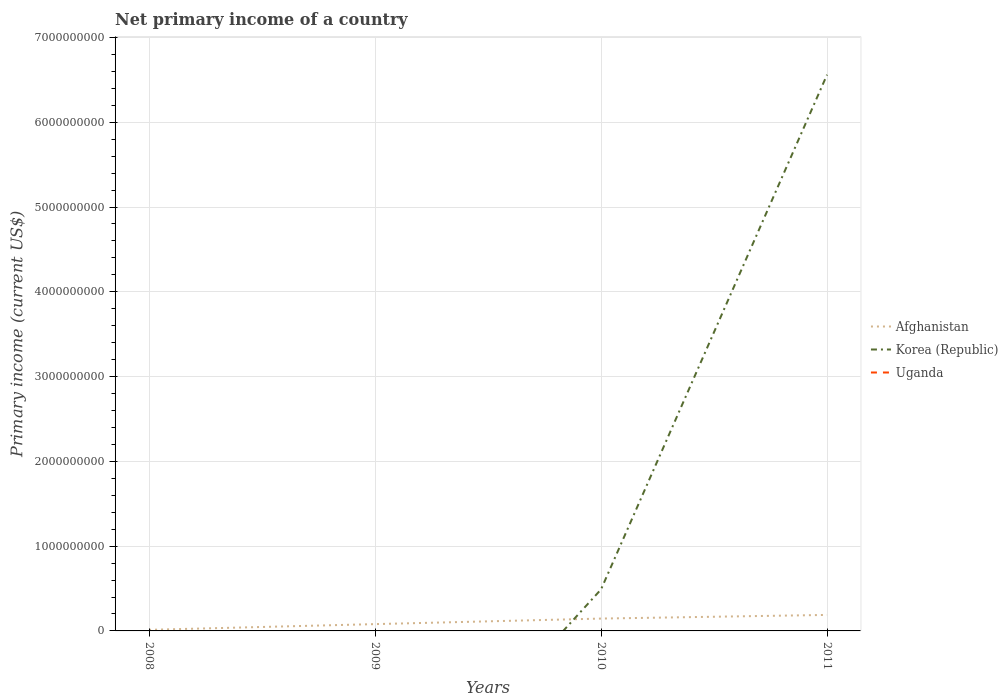Does the line corresponding to Uganda intersect with the line corresponding to Korea (Republic)?
Make the answer very short. Yes. Is the number of lines equal to the number of legend labels?
Offer a very short reply. No. Across all years, what is the maximum primary income in Afghanistan?
Ensure brevity in your answer.  1.28e+07. What is the total primary income in Korea (Republic) in the graph?
Provide a short and direct response. -6.07e+09. What is the difference between the highest and the second highest primary income in Afghanistan?
Your answer should be compact. 1.76e+08. What is the difference between the highest and the lowest primary income in Uganda?
Your response must be concise. 0. How many years are there in the graph?
Offer a very short reply. 4. How many legend labels are there?
Provide a short and direct response. 3. What is the title of the graph?
Make the answer very short. Net primary income of a country. Does "Georgia" appear as one of the legend labels in the graph?
Your answer should be very brief. No. What is the label or title of the Y-axis?
Make the answer very short. Primary income (current US$). What is the Primary income (current US$) in Afghanistan in 2008?
Your answer should be compact. 1.28e+07. What is the Primary income (current US$) of Korea (Republic) in 2008?
Your answer should be compact. 0. What is the Primary income (current US$) of Uganda in 2008?
Give a very brief answer. 0. What is the Primary income (current US$) of Afghanistan in 2009?
Your response must be concise. 8.03e+07. What is the Primary income (current US$) in Afghanistan in 2010?
Keep it short and to the point. 1.46e+08. What is the Primary income (current US$) in Korea (Republic) in 2010?
Keep it short and to the point. 4.90e+08. What is the Primary income (current US$) of Afghanistan in 2011?
Make the answer very short. 1.89e+08. What is the Primary income (current US$) in Korea (Republic) in 2011?
Provide a short and direct response. 6.56e+09. What is the Primary income (current US$) in Uganda in 2011?
Offer a very short reply. 0. Across all years, what is the maximum Primary income (current US$) of Afghanistan?
Provide a succinct answer. 1.89e+08. Across all years, what is the maximum Primary income (current US$) in Korea (Republic)?
Offer a terse response. 6.56e+09. Across all years, what is the minimum Primary income (current US$) in Afghanistan?
Offer a terse response. 1.28e+07. Across all years, what is the minimum Primary income (current US$) in Korea (Republic)?
Provide a short and direct response. 0. What is the total Primary income (current US$) of Afghanistan in the graph?
Your answer should be compact. 4.28e+08. What is the total Primary income (current US$) of Korea (Republic) in the graph?
Offer a very short reply. 7.05e+09. What is the total Primary income (current US$) of Uganda in the graph?
Offer a terse response. 0. What is the difference between the Primary income (current US$) in Afghanistan in 2008 and that in 2009?
Provide a short and direct response. -6.75e+07. What is the difference between the Primary income (current US$) in Afghanistan in 2008 and that in 2010?
Ensure brevity in your answer.  -1.33e+08. What is the difference between the Primary income (current US$) in Afghanistan in 2008 and that in 2011?
Give a very brief answer. -1.76e+08. What is the difference between the Primary income (current US$) of Afghanistan in 2009 and that in 2010?
Your answer should be very brief. -6.54e+07. What is the difference between the Primary income (current US$) of Afghanistan in 2009 and that in 2011?
Make the answer very short. -1.08e+08. What is the difference between the Primary income (current US$) in Afghanistan in 2010 and that in 2011?
Offer a very short reply. -4.31e+07. What is the difference between the Primary income (current US$) in Korea (Republic) in 2010 and that in 2011?
Make the answer very short. -6.07e+09. What is the difference between the Primary income (current US$) in Afghanistan in 2008 and the Primary income (current US$) in Korea (Republic) in 2010?
Ensure brevity in your answer.  -4.77e+08. What is the difference between the Primary income (current US$) of Afghanistan in 2008 and the Primary income (current US$) of Korea (Republic) in 2011?
Provide a succinct answer. -6.55e+09. What is the difference between the Primary income (current US$) in Afghanistan in 2009 and the Primary income (current US$) in Korea (Republic) in 2010?
Make the answer very short. -4.10e+08. What is the difference between the Primary income (current US$) in Afghanistan in 2009 and the Primary income (current US$) in Korea (Republic) in 2011?
Offer a very short reply. -6.48e+09. What is the difference between the Primary income (current US$) of Afghanistan in 2010 and the Primary income (current US$) of Korea (Republic) in 2011?
Keep it short and to the point. -6.41e+09. What is the average Primary income (current US$) in Afghanistan per year?
Provide a short and direct response. 1.07e+08. What is the average Primary income (current US$) in Korea (Republic) per year?
Give a very brief answer. 1.76e+09. In the year 2010, what is the difference between the Primary income (current US$) in Afghanistan and Primary income (current US$) in Korea (Republic)?
Make the answer very short. -3.44e+08. In the year 2011, what is the difference between the Primary income (current US$) in Afghanistan and Primary income (current US$) in Korea (Republic)?
Your answer should be very brief. -6.37e+09. What is the ratio of the Primary income (current US$) in Afghanistan in 2008 to that in 2009?
Offer a terse response. 0.16. What is the ratio of the Primary income (current US$) in Afghanistan in 2008 to that in 2010?
Your answer should be very brief. 0.09. What is the ratio of the Primary income (current US$) in Afghanistan in 2008 to that in 2011?
Provide a succinct answer. 0.07. What is the ratio of the Primary income (current US$) of Afghanistan in 2009 to that in 2010?
Ensure brevity in your answer.  0.55. What is the ratio of the Primary income (current US$) in Afghanistan in 2009 to that in 2011?
Offer a terse response. 0.43. What is the ratio of the Primary income (current US$) of Afghanistan in 2010 to that in 2011?
Keep it short and to the point. 0.77. What is the ratio of the Primary income (current US$) of Korea (Republic) in 2010 to that in 2011?
Provide a succinct answer. 0.07. What is the difference between the highest and the second highest Primary income (current US$) in Afghanistan?
Your response must be concise. 4.31e+07. What is the difference between the highest and the lowest Primary income (current US$) of Afghanistan?
Provide a short and direct response. 1.76e+08. What is the difference between the highest and the lowest Primary income (current US$) of Korea (Republic)?
Your answer should be very brief. 6.56e+09. 